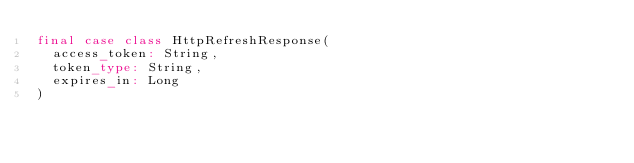Convert code to text. <code><loc_0><loc_0><loc_500><loc_500><_Scala_>final case class HttpRefreshResponse(
  access_token: String,
  token_type: String,
  expires_in: Long
)
</code> 